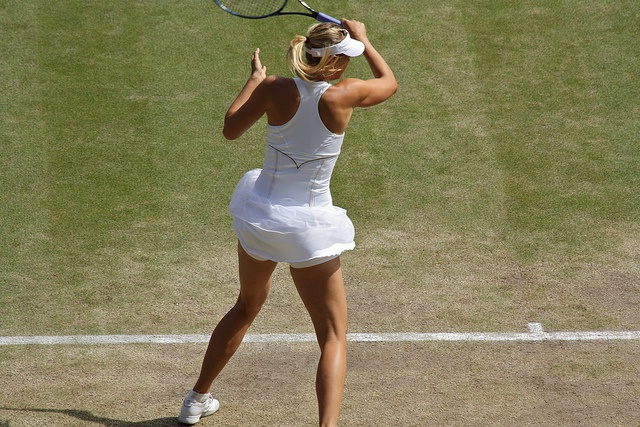Describe the objects in this image and their specific colors. I can see people in olive, maroon, gray, black, and darkgray tones and tennis racket in olive and black tones in this image. 